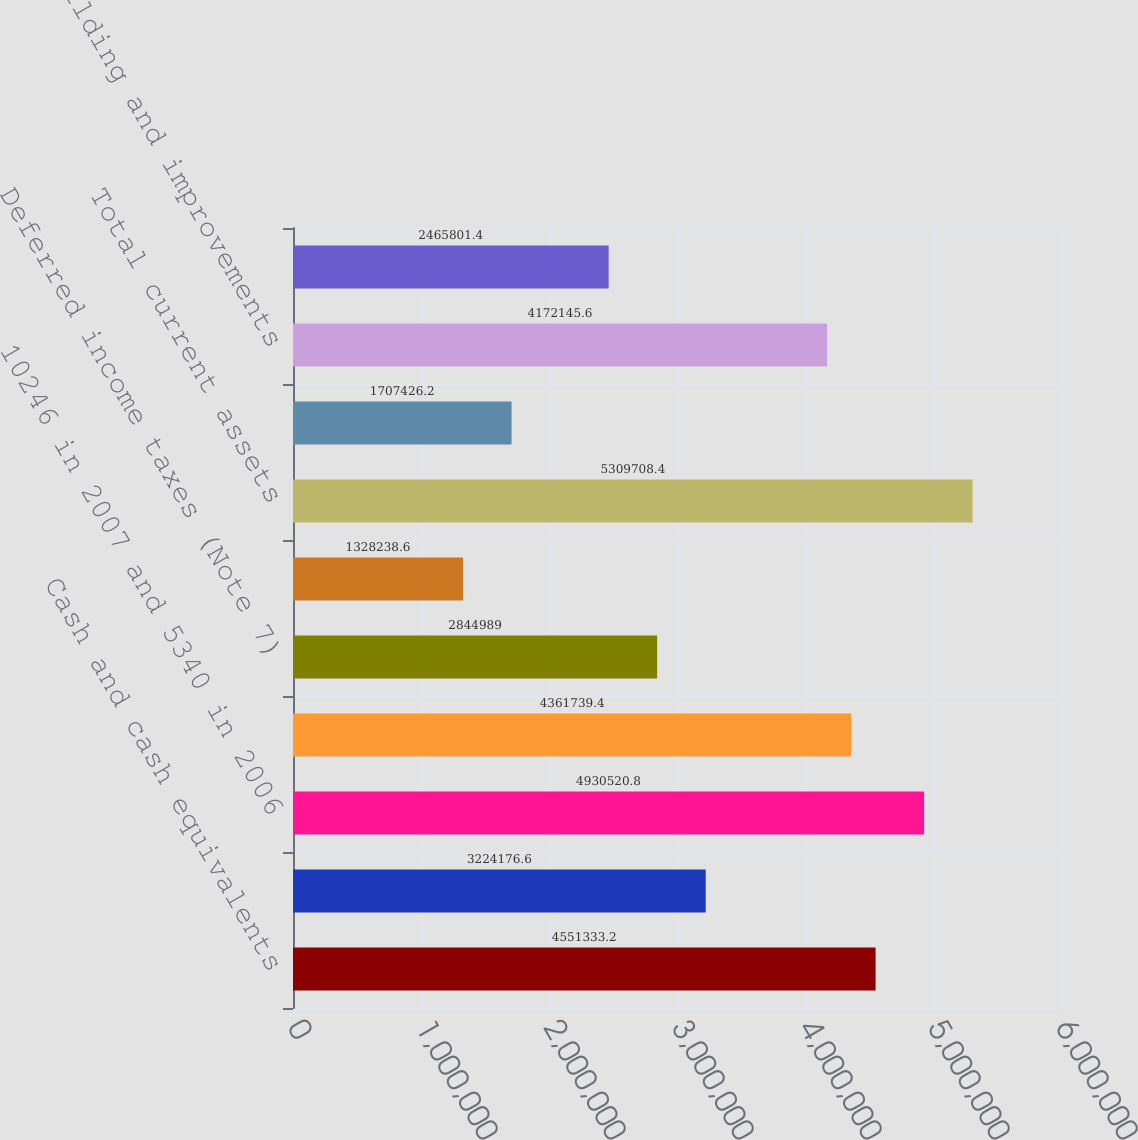<chart> <loc_0><loc_0><loc_500><loc_500><bar_chart><fcel>Cash and cash equivalents<fcel>Marketable securities ( Note<fcel>10246 in 2007 and 5340 in 2006<fcel>Inventories net (Note 3)<fcel>Deferred income taxes (Note 7)<fcel>Prepaid expenses and other<fcel>Total current assets<fcel>Land and improvements<fcel>Building and improvements<fcel>Office furniture and equipment<nl><fcel>4.55133e+06<fcel>3.22418e+06<fcel>4.93052e+06<fcel>4.36174e+06<fcel>2.84499e+06<fcel>1.32824e+06<fcel>5.30971e+06<fcel>1.70743e+06<fcel>4.17215e+06<fcel>2.4658e+06<nl></chart> 